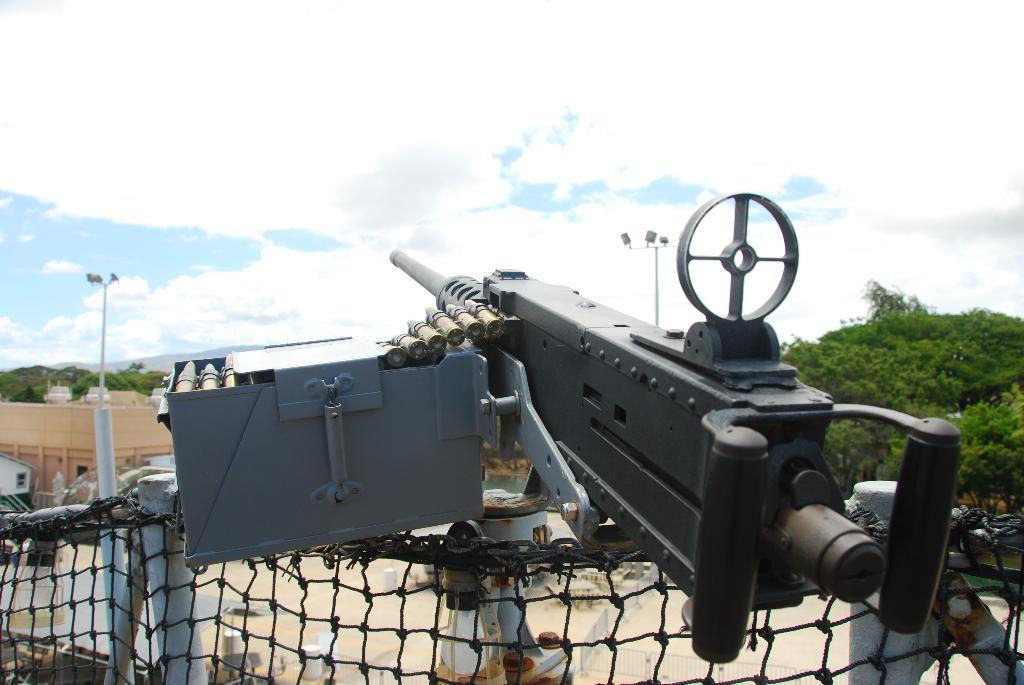What objects are in the image related to firearms? There is a gun with a box and bullets in the image. How are the gun and bullets positioned in the image? The gun and bullets are on a net in the image. What other objects can be seen in the image? There are rods and a pole in the image. What can be seen in the background of the image? There is a building, trees, and the sky visible in the background of the image. What is the condition of the sky in the image? Clouds are present in the sky in the image. What type of transport can be seen in the image? There is no transport visible in the image. Is there a guitar being played in the image? There is no guitar present in the image. 